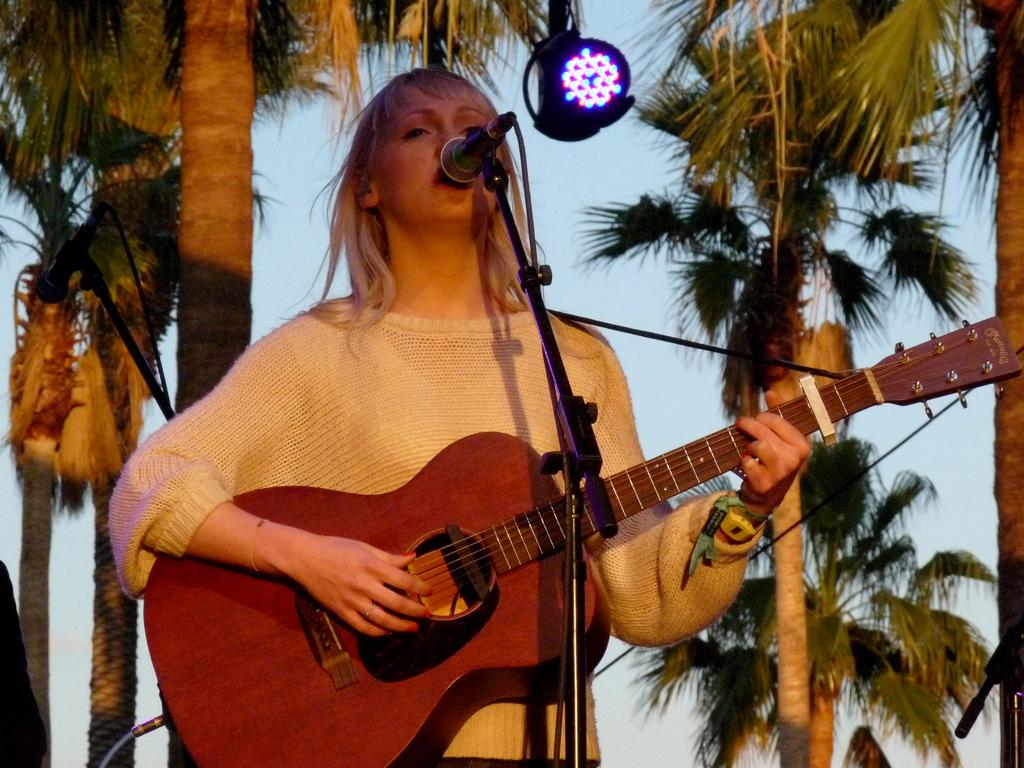Who is the main subject in the image? There is a lady in the image. What is the lady doing in the image? The lady is playing a guitar and singing. What object is in front of the lady? There is a microphone in front of the lady. What can be seen in the background of the image? There are trees and the sky visible in the background of the image. What type of lighting is present in the image? There are lights visible in the image. Can you tell me how many friends the lady has with her in the image? There is no mention of friends in the image; it only shows the lady playing a guitar and singing. What type of donkey can be seen in the image? There is no donkey present in the image. 